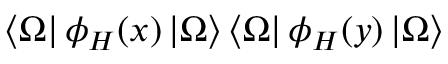Convert formula to latex. <formula><loc_0><loc_0><loc_500><loc_500>\left < \Omega \right | \phi _ { H } ( x ) \left | \Omega \right > \left < \Omega \right | \phi _ { H } ( y ) \left | \Omega \right ></formula> 